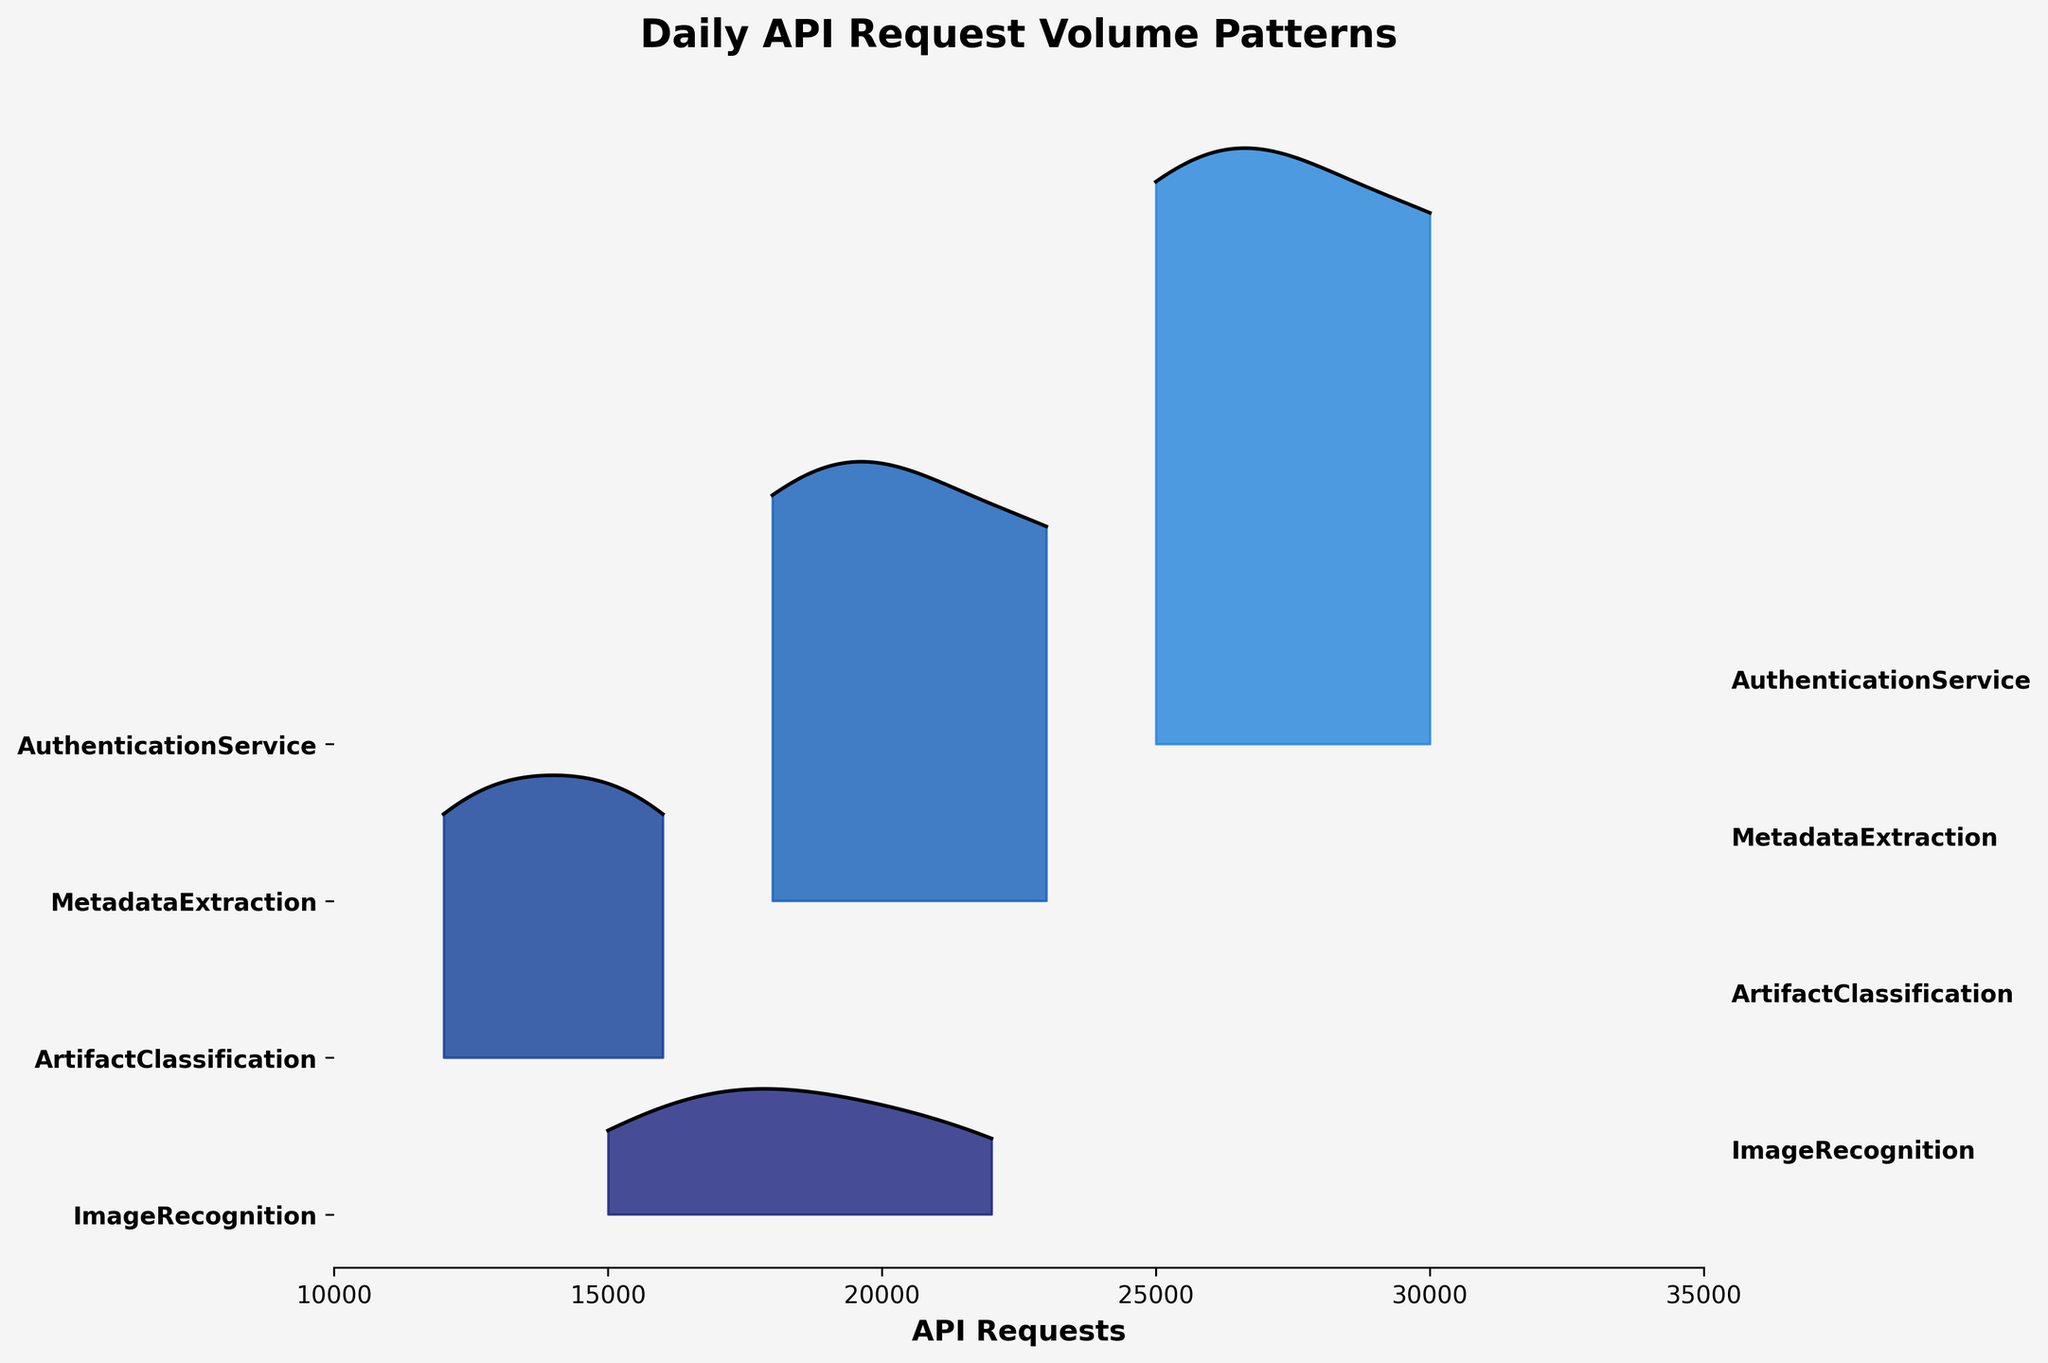What's the title of the figure? The title of a figure is usually displayed prominently at the top. For this figure, the title is stated clearly.
Answer: Daily API Request Volume Patterns Which microservice had the highest peak in API requests? To find the highest peak, look at the highest point on the ridgeline plot along the vertical axis. The AuthenticationService consistently has higher peaks than other services.
Answer: AuthenticationService What is the color of the line representing MetadataExtraction service? Each ridgeline plot line is colored differently. MetadataExtraction service is represented by a line colored in a medium blue shade.
Answer: Medium blue How many different microservices are displayed in the plot? Each microservice is represented by one ridgeline, and there are four distinct ridgelines displayed. Therefore, there are four microservices.
Answer: 4 What is the approximate range of API requests volume for ArtifactClassification? Look at the x-axis range for ArtifactClassification which is labeled on the y-axis and assess its spread horizontally. It ranges from approximately 12,000 to 16,000 requests.
Answer: Approximately 12,000 to 16,000 What's the difference in peak API requests between ImageRecognition and MetadataExtraction on May 22? Identify the peaks for the given date on the ridgeline plot and calculate the difference. ImageRecognition peaks at 20,000 and MetadataExtraction at 21,000 on May 22, so the difference is 1,000.
Answer: 1,000 Which microservice shows the most consistent (least variable) API request volume across the dates? Consistent volume can be observed by noting the narrowest spread in the ridgeline plot for each service. ArtifactClassification's spread is relatively narrow, indicating consistent volume.
Answer: ArtifactClassification How does the API request volume for AuthenticationService on May 15 compare to MetadataExtraction on the same date? Examine the peaks for both services on the given date and compare their values. AuthenticationService had about 30,000 requests whereas MetadataExtraction had about 23,000. AuthenticationService had significantly more requests.
Answer: AuthenticationService had more requests What's the average peak API request volume across all microservices on May 08? Identify and add the peak API requests for each service on May 08 (18,000 + 14,000 + 20,000 + 27,000) and then divide by the number of services (4). (18,000 + 14,000 + 20,000 + 27,000) / 4 = 19,750.
Answer: 19,750 